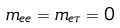Convert formula to latex. <formula><loc_0><loc_0><loc_500><loc_500>m _ { e e } = m _ { e \tau } = 0</formula> 